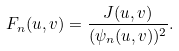Convert formula to latex. <formula><loc_0><loc_0><loc_500><loc_500>F _ { n } ( u , v ) = \frac { J ( u , v ) } { ( \psi _ { n } ( u , v ) ) ^ { 2 } } .</formula> 